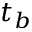<formula> <loc_0><loc_0><loc_500><loc_500>t _ { b }</formula> 